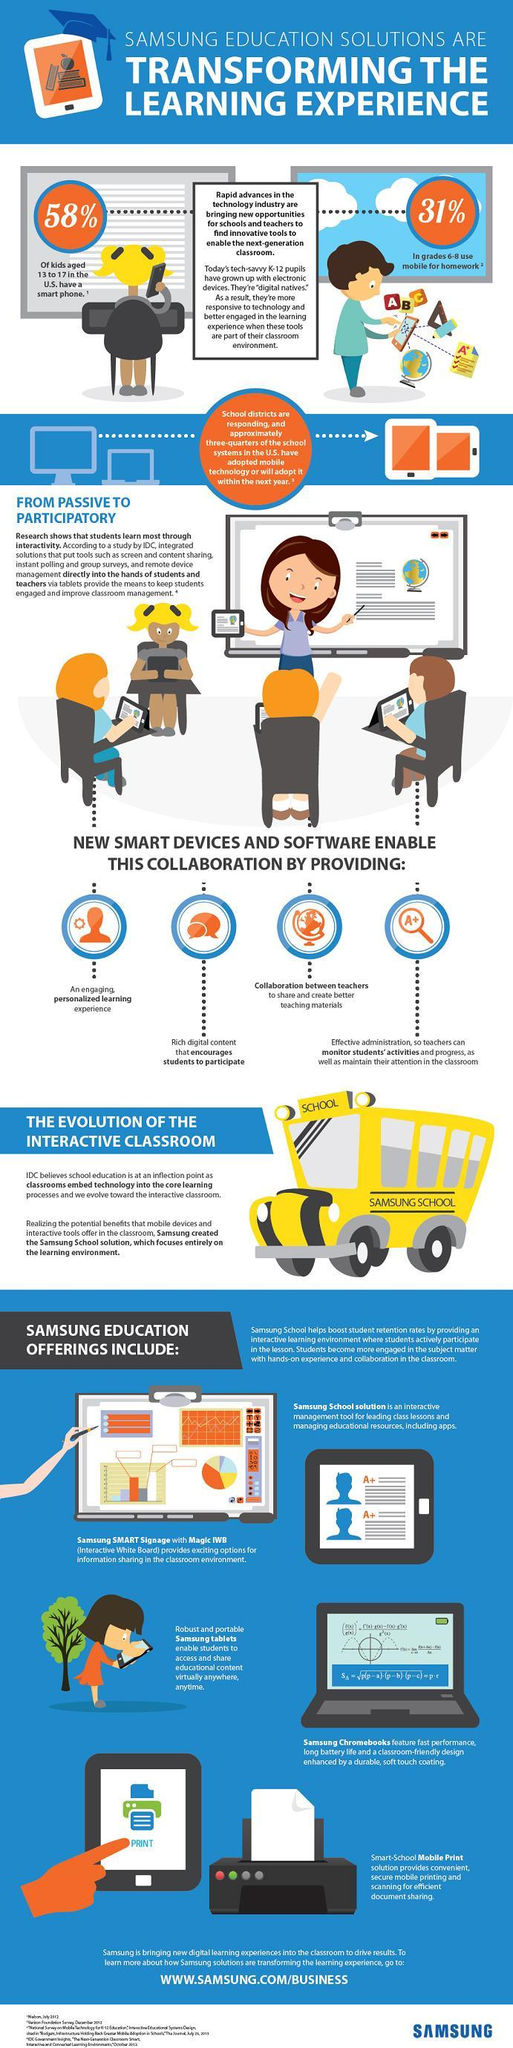What percentage of students in grade 6-8 use mobile for homework in the U.S.?
Answer the question with a short phrase. 31% What percentage of kids aged 13 to 17 in the U.S. have a smart phone? 58% 